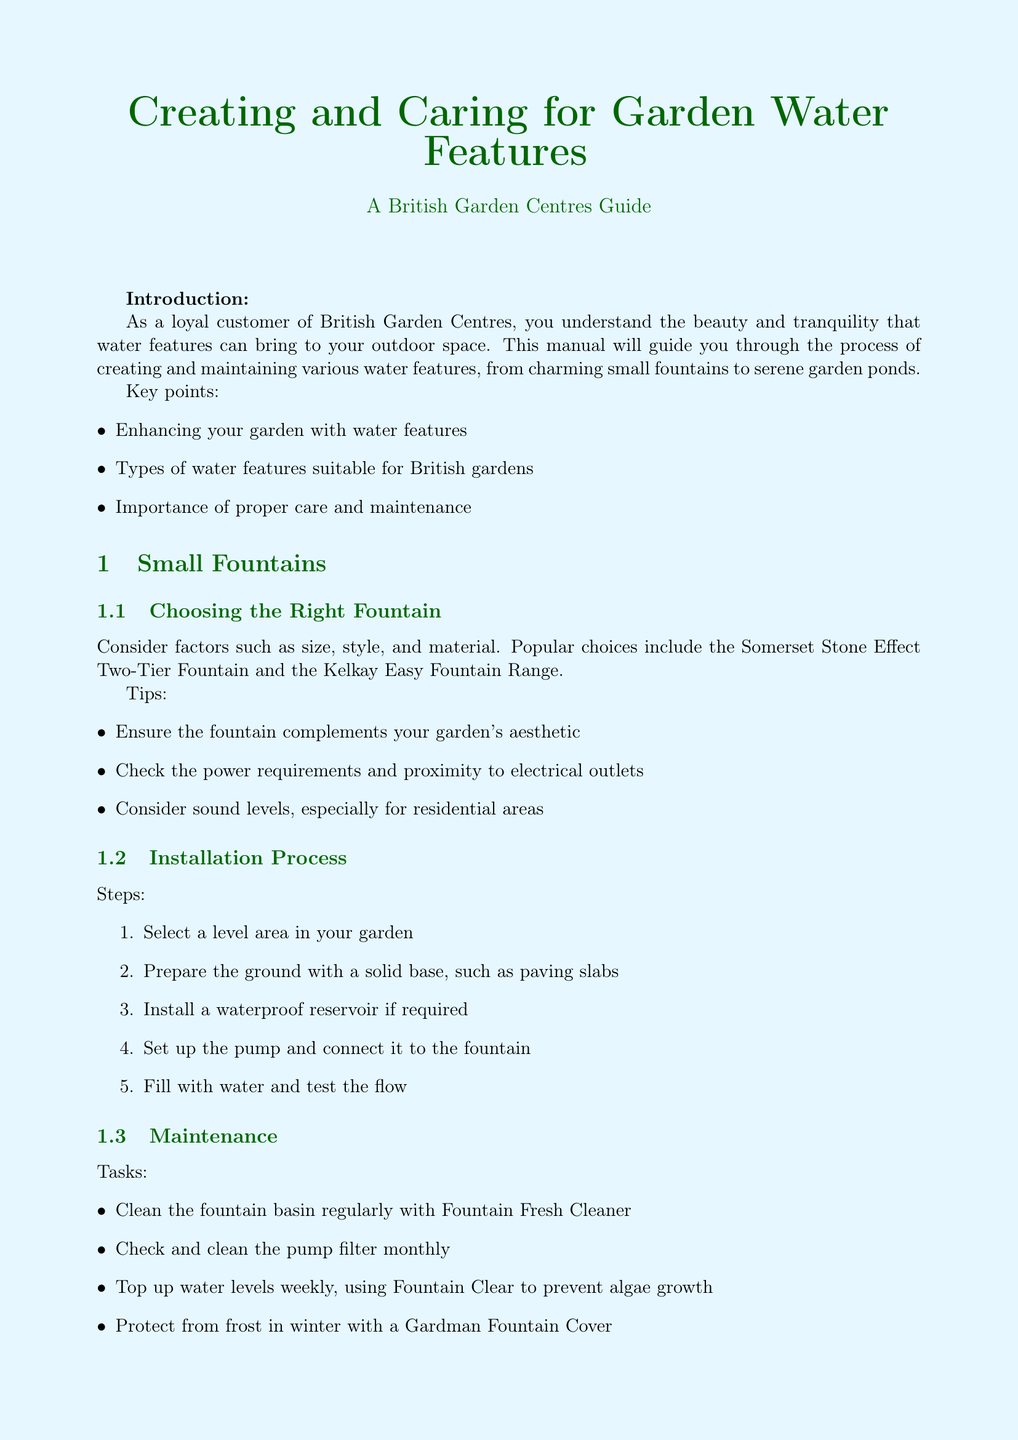what is the title of the manual? The title of the manual is specified at the beginning of the document.
Answer: Creating and Caring for Garden Water Features: A British Garden Centres Guide what is a popular choice for a small fountain? The document mentions specific fountain models as popular choices in the small fountains section.
Answer: Somerset Stone Effect Two-Tier Fountain what is the minimum depth recommended for a pond? The manual gives specific guidelines for pond depth within the planning section.
Answer: 60cm name one oxygenating plant suggested for ponds. The document lists specific types of plants suitable for stocking ponds.
Answer: Elodea crispa what is one task for the maintenance of a garden pond? The maintenance section provides a list of tasks required for proper pond care.
Answer: Test water quality weekly with a Pondlab Multi-Test Kit what kind of features should be avoided when planning a pond location? Reasoning about the safety and ecology of pond planning leads to considerations regarding specific features.
Answer: Areas under trees name a service offered by British Garden Centres. The resources section details various services that the garden centres provide.
Answer: Pond Care Clinic how often should you clean the water distribution system in a water wall feature? The care and maintenance section states specific intervals for cleaning tasks related to water wall features.
Answer: Monthly 